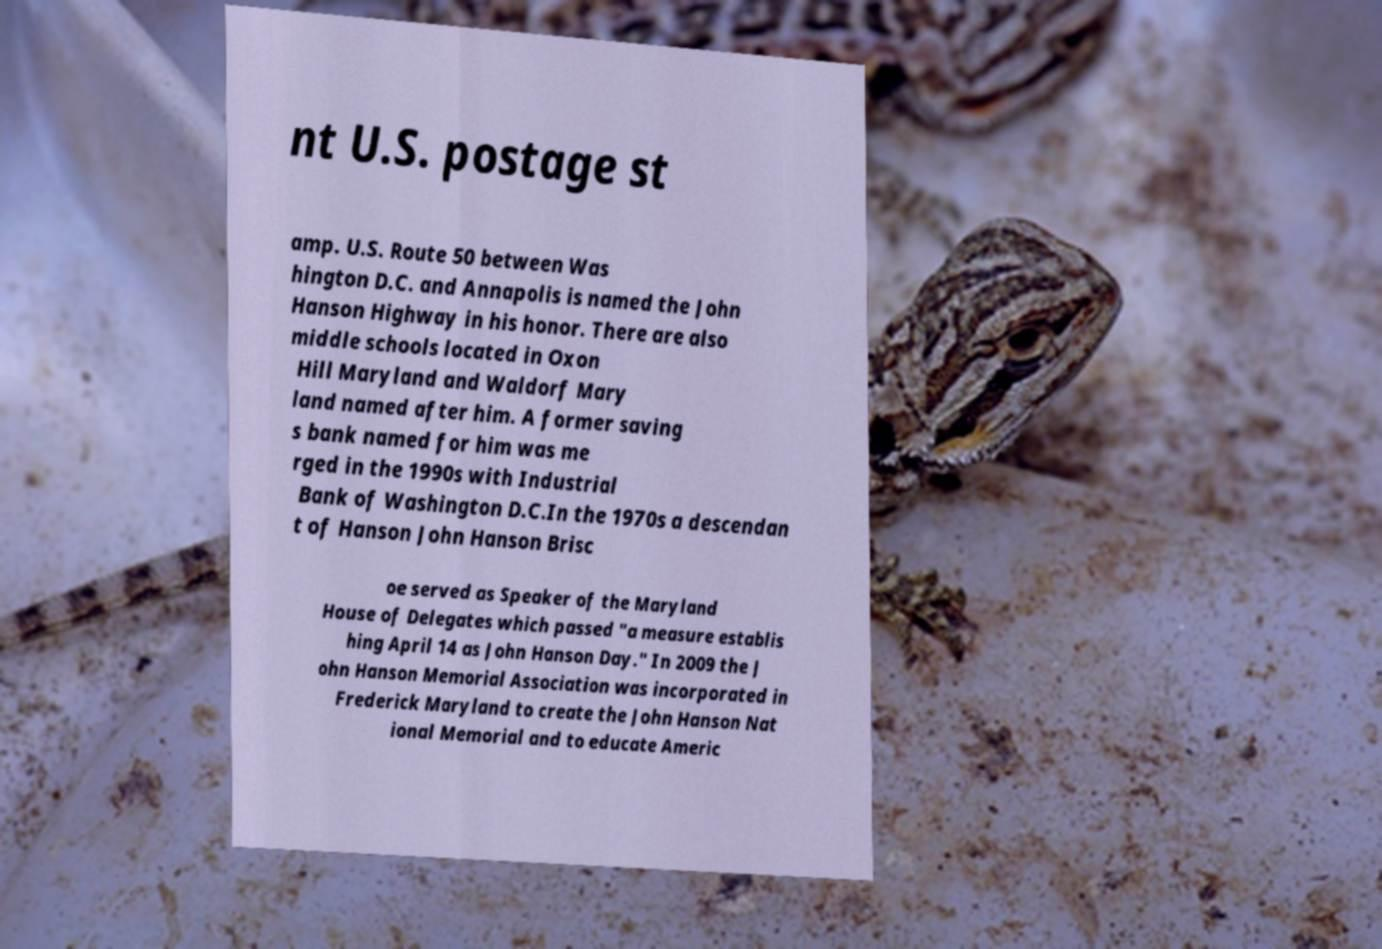Can you read and provide the text displayed in the image?This photo seems to have some interesting text. Can you extract and type it out for me? nt U.S. postage st amp. U.S. Route 50 between Was hington D.C. and Annapolis is named the John Hanson Highway in his honor. There are also middle schools located in Oxon Hill Maryland and Waldorf Mary land named after him. A former saving s bank named for him was me rged in the 1990s with Industrial Bank of Washington D.C.In the 1970s a descendan t of Hanson John Hanson Brisc oe served as Speaker of the Maryland House of Delegates which passed "a measure establis hing April 14 as John Hanson Day." In 2009 the J ohn Hanson Memorial Association was incorporated in Frederick Maryland to create the John Hanson Nat ional Memorial and to educate Americ 